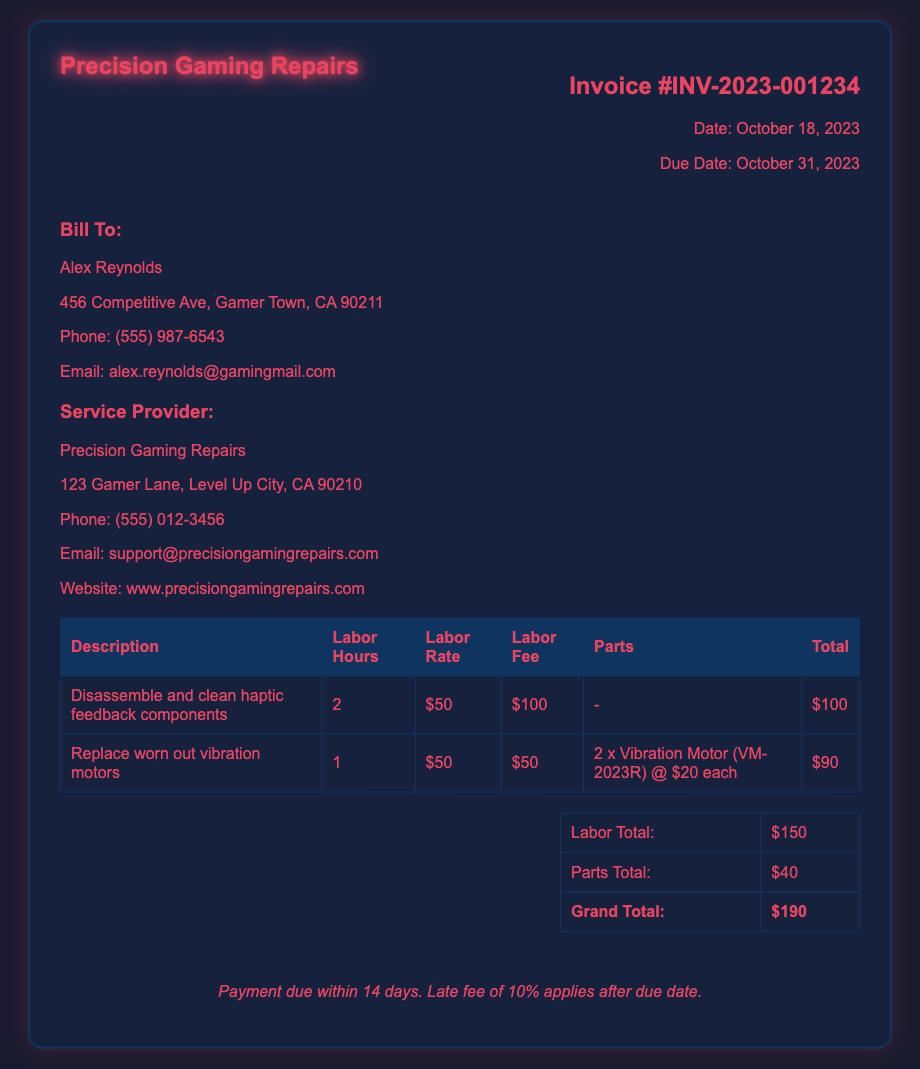What is the invoice number? The invoice number is clearly stated in the document as a unique identifier for the transaction.
Answer: INV-2023-001234 What is the total labor fee? The total labor fee is calculated from the labor hours and labor rate, summed up from the services provided.
Answer: $150 What is the date of service? The date of service is noted on the invoice, which establishes when the repairs were completed.
Answer: October 18, 2023 Who is the service provider? The service provider's name appears prominently in the document, indicating who performed the repair services.
Answer: Precision Gaming Repairs What is the parts total? The parts total is a specific amount that accounts for the items replaced during the service.
Answer: $40 How many vibration motors were replaced? The document specifies the number of parts that were installed or replaced during the repair process.
Answer: 2 What is the due date for payment? The due date is crucial for understanding the timeline for when payment is expected.
Answer: October 31, 2023 What is the late fee percentage? The document outlines the consequences of late payment by specifying a percentage of the total invoice amount.
Answer: 10% What item was disassembled and cleaned? The invoice lists specific tasks completed as part of the repair, highlighting the services rendered.
Answer: haptic feedback components 